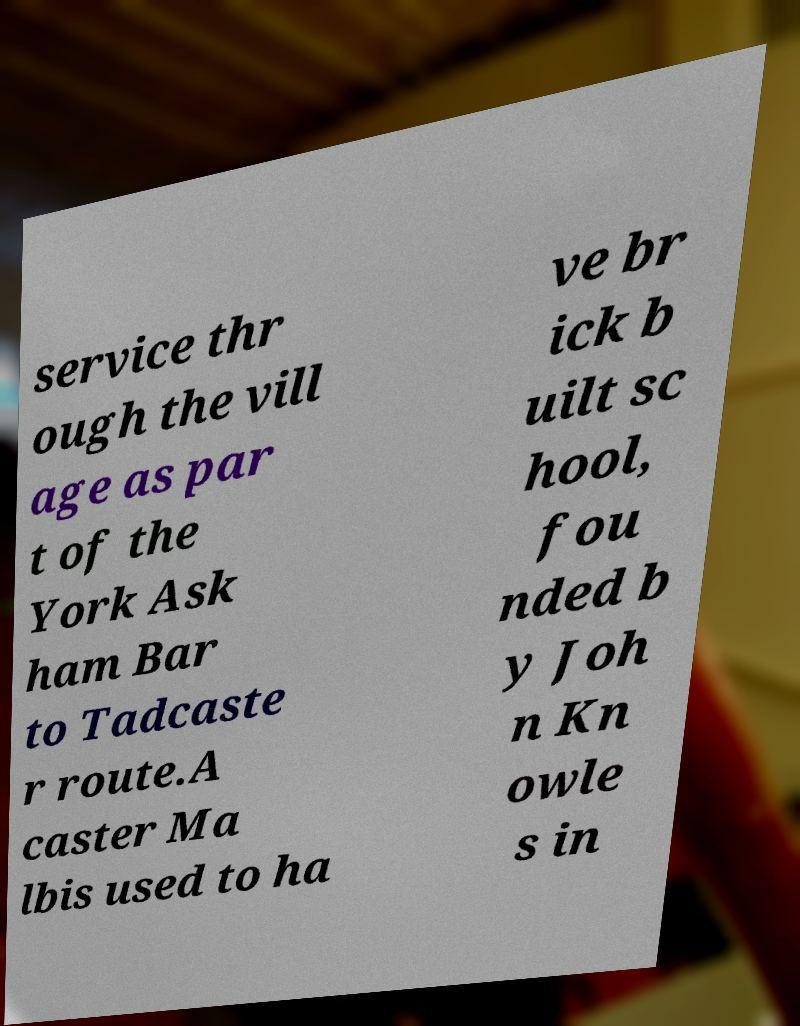Could you assist in decoding the text presented in this image and type it out clearly? service thr ough the vill age as par t of the York Ask ham Bar to Tadcaste r route.A caster Ma lbis used to ha ve br ick b uilt sc hool, fou nded b y Joh n Kn owle s in 